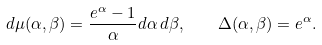<formula> <loc_0><loc_0><loc_500><loc_500>d \mu ( \alpha , \beta ) = \frac { e ^ { \alpha } - 1 } { \alpha } d \alpha \, d \beta , \quad \Delta ( \alpha , \beta ) = e ^ { \alpha } .</formula> 